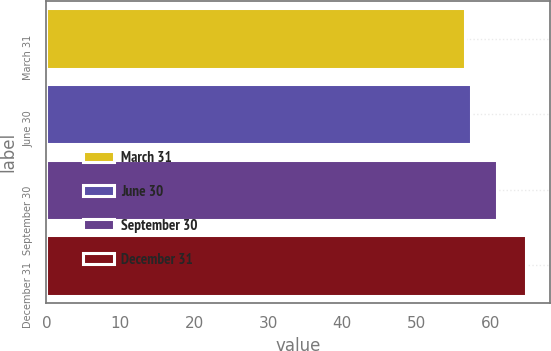<chart> <loc_0><loc_0><loc_500><loc_500><bar_chart><fcel>March 31<fcel>June 30<fcel>September 30<fcel>December 31<nl><fcel>56.57<fcel>57.4<fcel>60.91<fcel>64.89<nl></chart> 